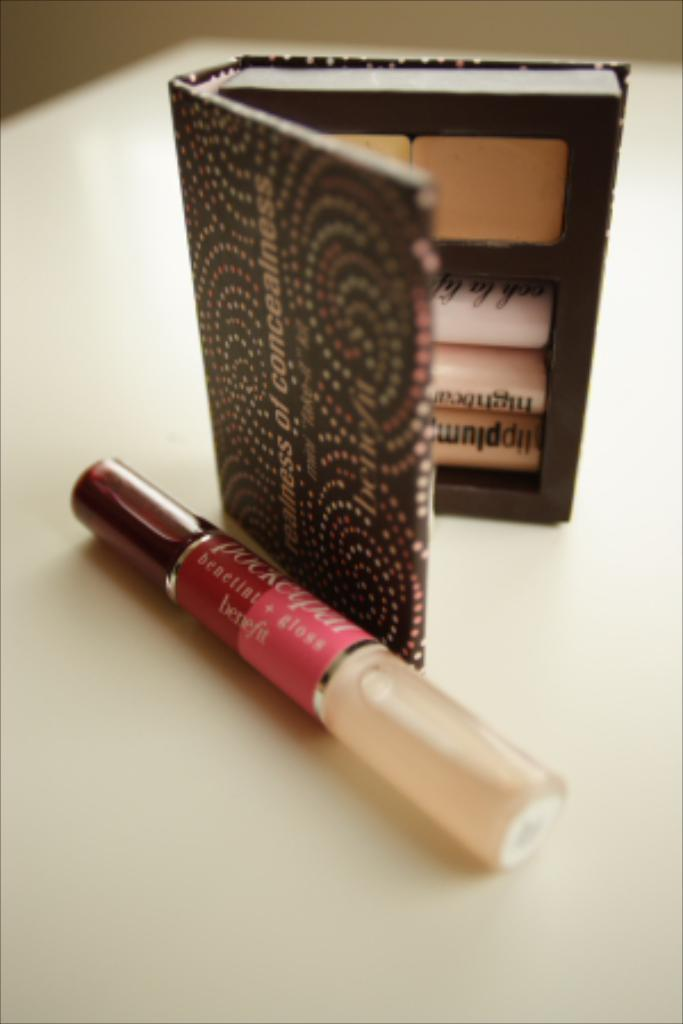What is located at the bottom of the image? There is a table at the bottom of the image. What items can be seen on the table? There is an eye shadow kit and a lip gloss bottle on the table. What can be seen in the background of the image? There is a wall in the background of the image. What time of day is depicted in the image? The time of day is not mentioned in the image, so it cannot be determined from the image alone. 